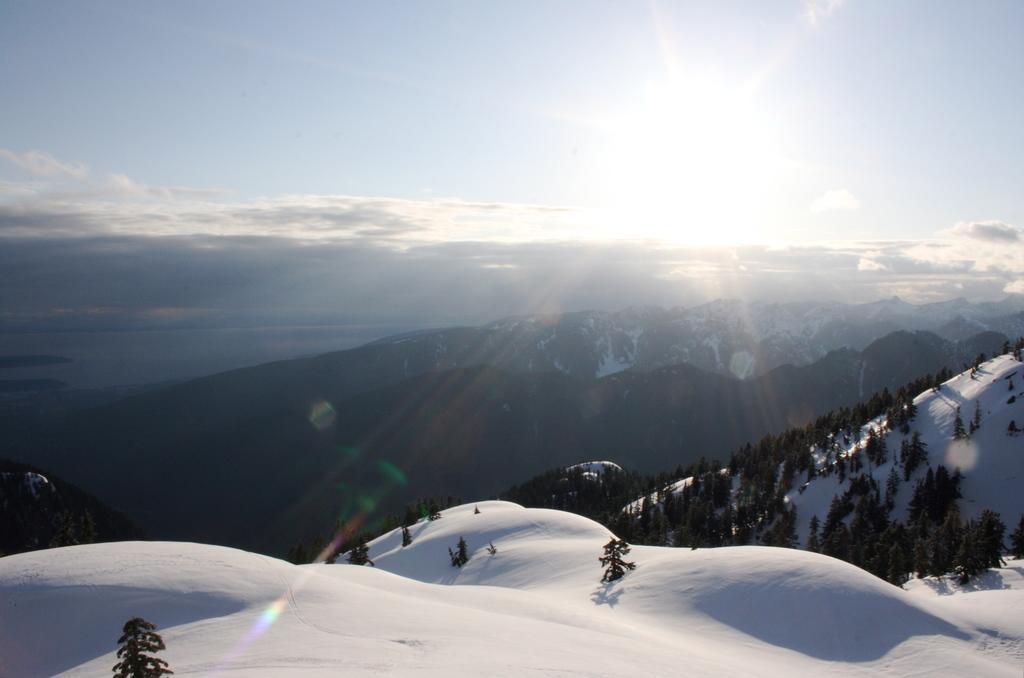Can you describe this image briefly? In this image we can see some trees, mountains and the snow, in the background, we can see the sky with clouds. 